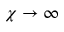<formula> <loc_0><loc_0><loc_500><loc_500>\chi \to \infty</formula> 